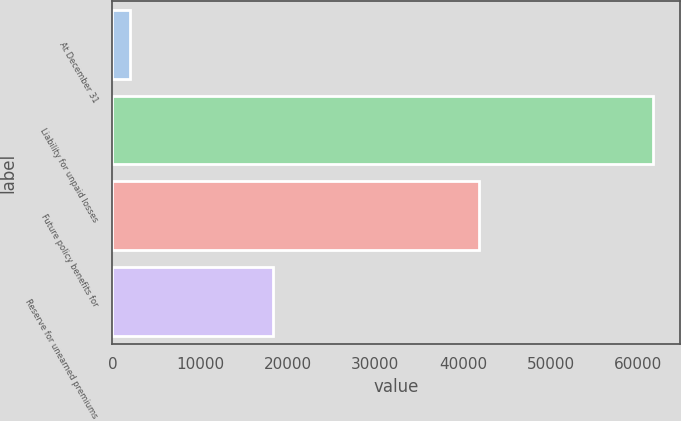Convert chart to OTSL. <chart><loc_0><loc_0><loc_500><loc_500><bar_chart><fcel>At December 31<fcel>Liability for unpaid losses<fcel>Future policy benefits for<fcel>Reserve for unearned premiums<nl><fcel>2014<fcel>61612<fcel>41767<fcel>18278<nl></chart> 